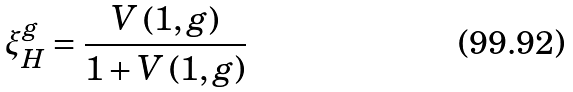<formula> <loc_0><loc_0><loc_500><loc_500>\xi _ { H } ^ { g } = \frac { V \left ( 1 , g \right ) } { 1 + V \left ( 1 , g \right ) }</formula> 